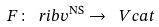Convert formula to latex. <formula><loc_0><loc_0><loc_500><loc_500>F \colon \ r i b v ^ { \text {NS} } \rightarrow \ V c a t</formula> 